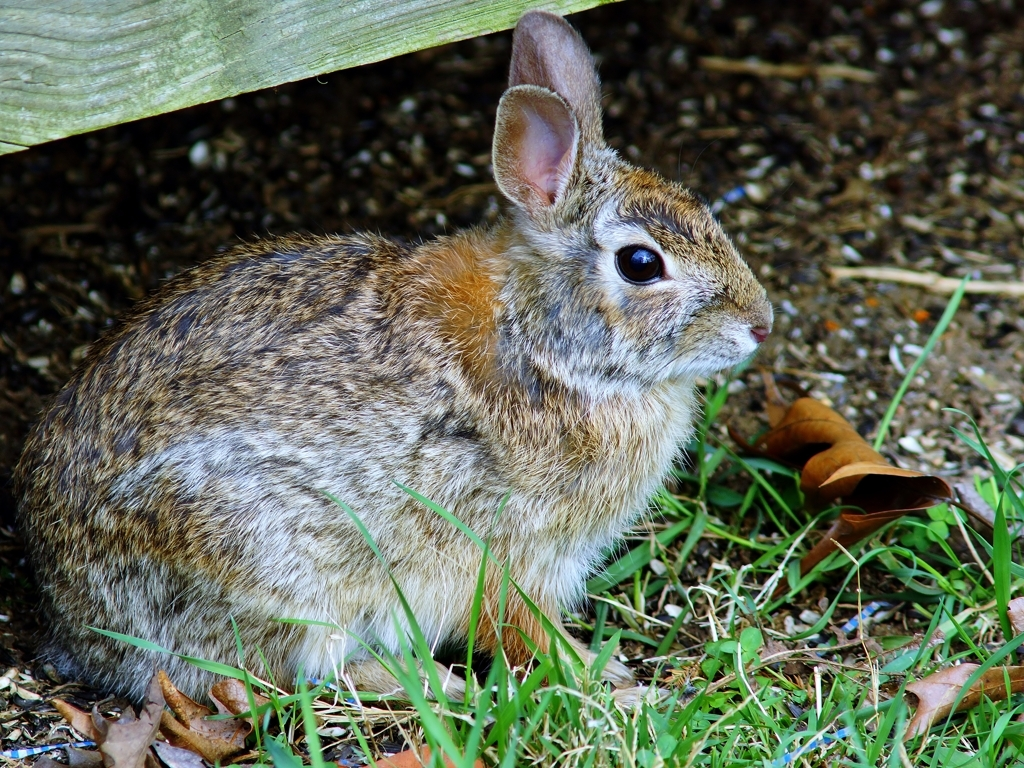Is this rabbit in a natural habitat, and how can it be deduced from the image? Yes, it seems to be in a natural or semi-natural habitat. You can deduce this from the natural ground cover, the presence of leaves that suggest woodland or forest edge, and the sheltering structure it's near which might be indicative of a human-influenced environment like a garden or park. 